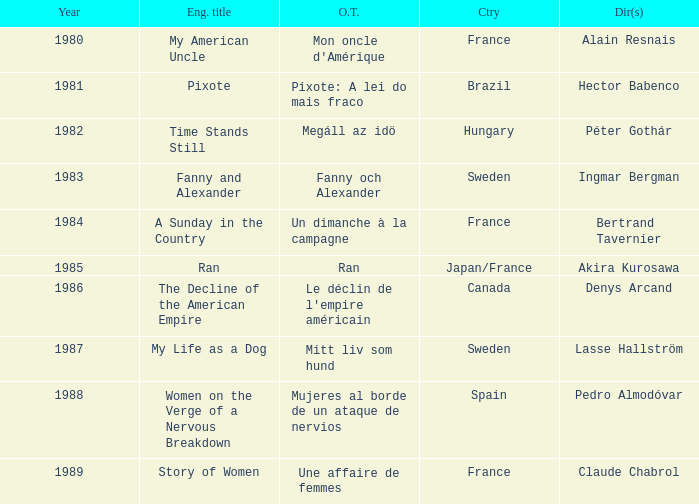What was the year of Megáll az Idö? 1982.0. 